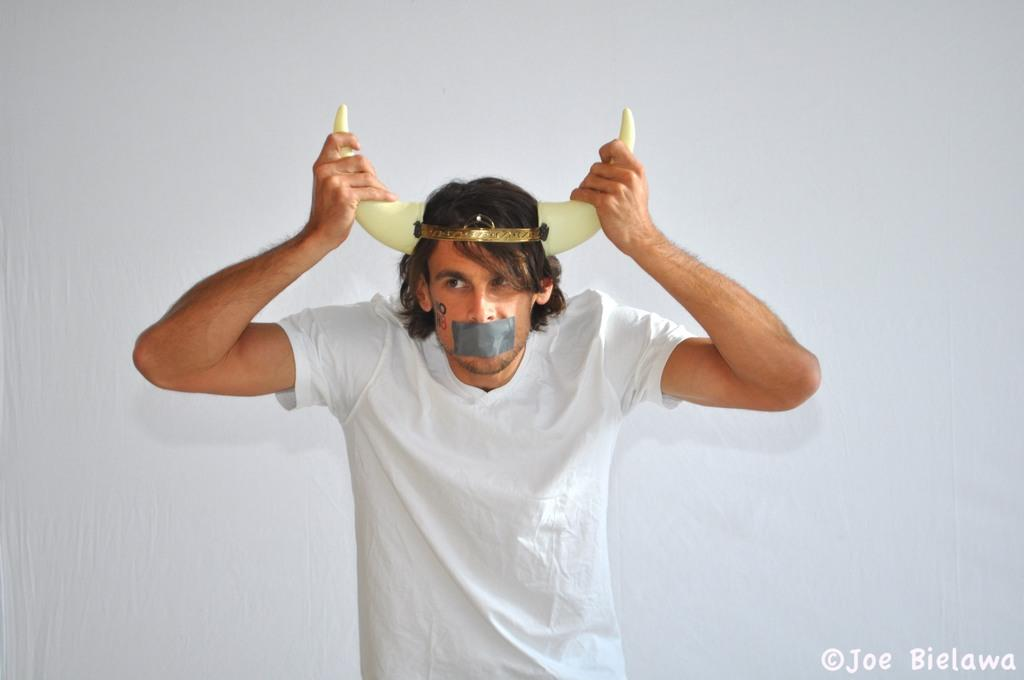What is the main subject of the image? There is a man in the image. What is the man doing in the image? The man is standing. What is the man wearing in the image? The man is wearing a white t-shirt. What is covering the man's mouth in the image? There is a tape on the man's mouth. What is unique about the man's appearance in the image? The man has horns on his head. What is the color of the background in the image? The background of the image is white. What type of door can be seen in the image? There is no door present in the image. What is the man doing during the war in the image? There is no war depicted in the image, and the man's actions are limited to standing. 